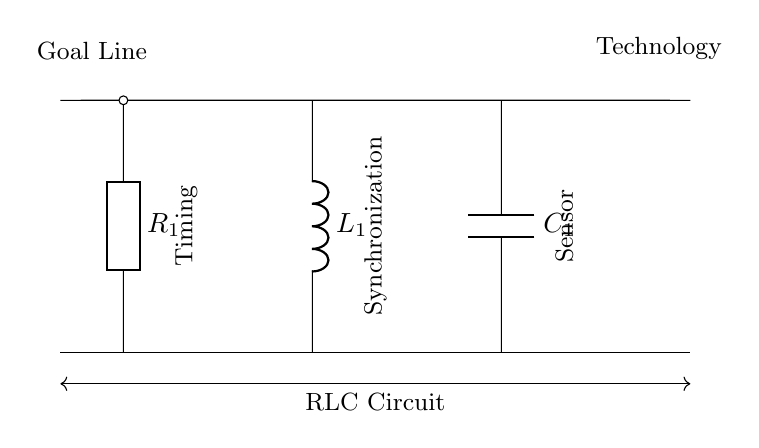What are the components of this RLC circuit? The circuit contains a resistor, an inductor, and a capacitor. These are labeled R, L, and C respectively in the diagram, representing their roles in the circuit.
Answer: Resistor, Inductor, Capacitor What is the role of the resistor in this circuit? The resistor limits the current flow and helps control the timing and damping in the circuit. It is essential for managing the voltage drop across components.
Answer: Current Limiting What is the primary purpose of this RLC circuit in goal line technology? The primary purpose is timing and synchronization of the sensor signals to accurately determine if the ball has crossed the goal line. This precision is crucial for the system's effectiveness.
Answer: Timing and Synchronization What component is closest to the timing section of the circuit? The resistor is immediately adjacent to the timing section labeled in the diagram, indicating its direct involvement in this function.
Answer: Resistor What happens to the circuit's behavior when the inductor value is increased? Increasing the inductor value typically results in a longer time constant, which can lead to slower response times in the circuit's reaction to changes, affecting timing and synchronization. This is due to the inductor resisting changes in current.
Answer: Slower Response How does the capacitor affect the synchronization in the circuit? The capacitor stores and releases energy, which affects the timing of signal changes. In synchronization, it helps manage the phase relationship between voltage and current, making sure the signals are properly timed.
Answer: Energy Storage 